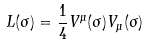Convert formula to latex. <formula><loc_0><loc_0><loc_500><loc_500>L ( \sigma ) = \frac { 1 } { 4 } V ^ { \mu } ( \sigma ) V _ { \mu } ( \sigma )</formula> 